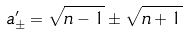Convert formula to latex. <formula><loc_0><loc_0><loc_500><loc_500>a ^ { \prime } _ { \pm } = \sqrt { n - 1 } \pm \sqrt { n + 1 }</formula> 